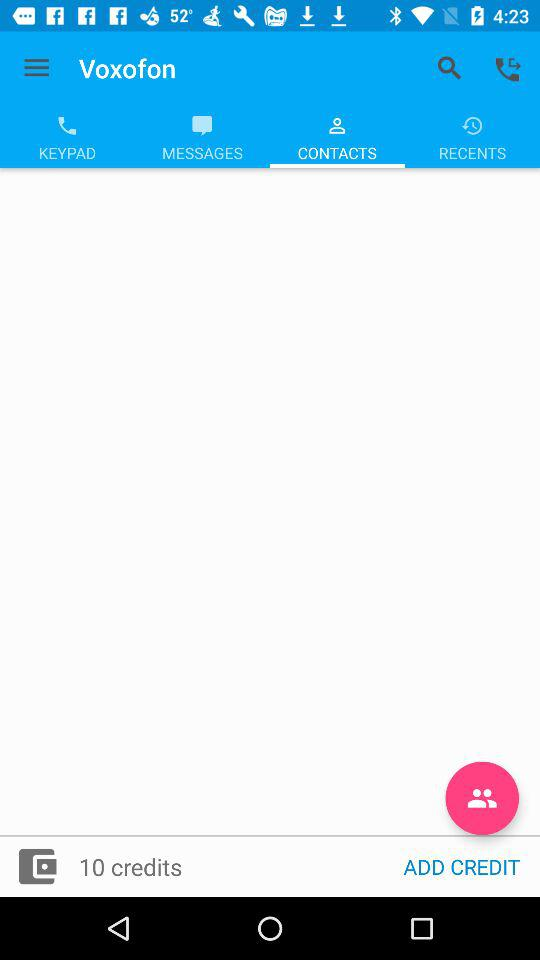How many credits do I have?
Answer the question using a single word or phrase. 10 